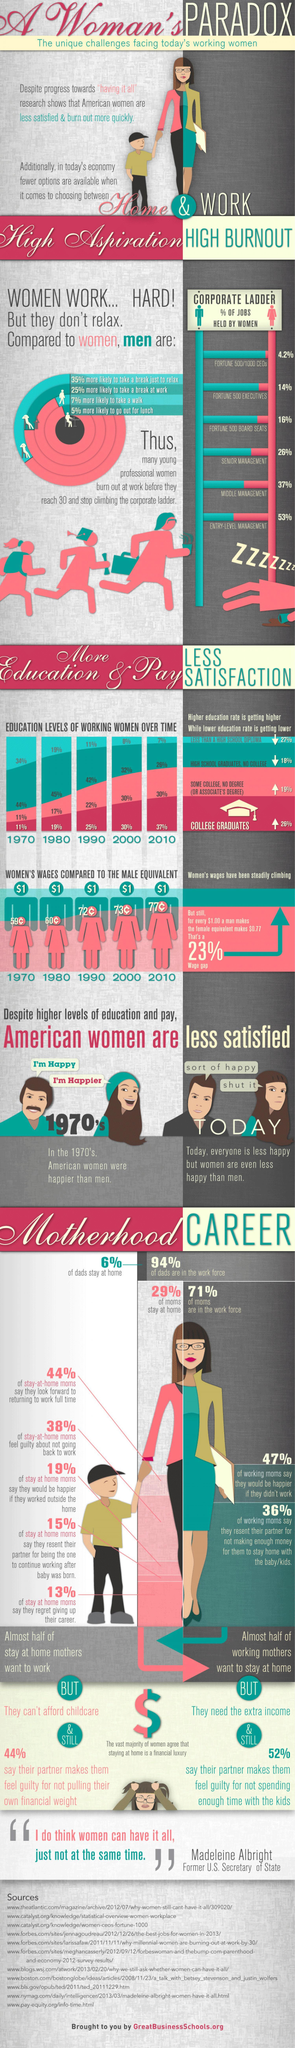What is the average percentage increase in college graduates over five decades?
Answer the question with a short phrase. 24.4% What percentage of men who take a career break for childcare, 71%, 29%, 94%, or 6%? 6% What percentage of women are less likely go out for lunch? 95% What percentage of men would take a recess from work? 25% By how much is the woman's wage lower than men in the year 2010 in cents? 23 cents Which role has the fourth  least percentage of women in the corporate ladder? Senior Management What was the percentage of women getting Associate degree and College Graduation in 2000? 30% 